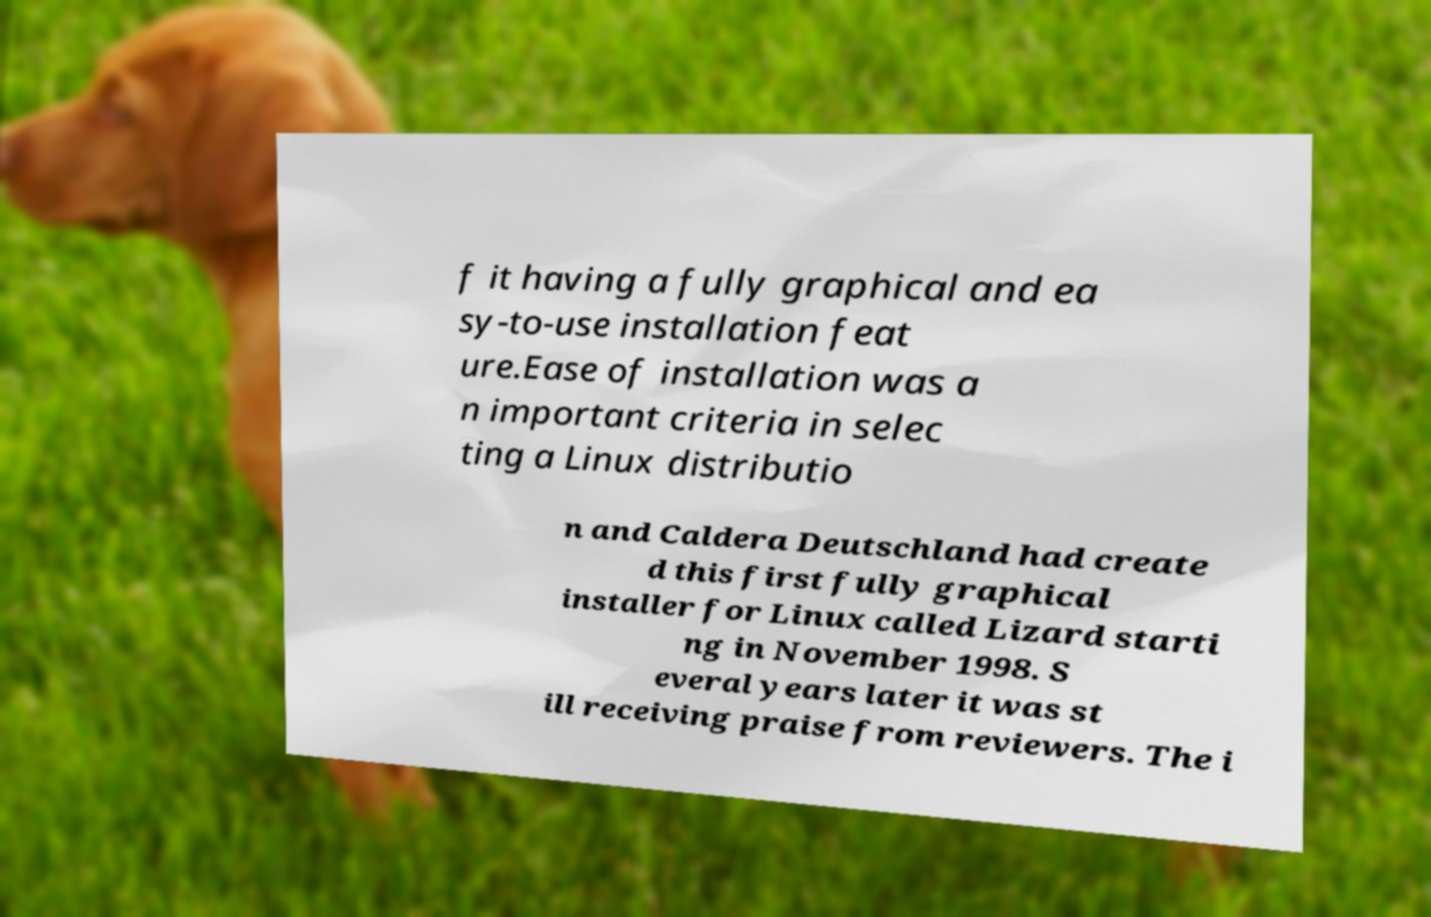Please read and relay the text visible in this image. What does it say? f it having a fully graphical and ea sy-to-use installation feat ure.Ease of installation was a n important criteria in selec ting a Linux distributio n and Caldera Deutschland had create d this first fully graphical installer for Linux called Lizard starti ng in November 1998. S everal years later it was st ill receiving praise from reviewers. The i 